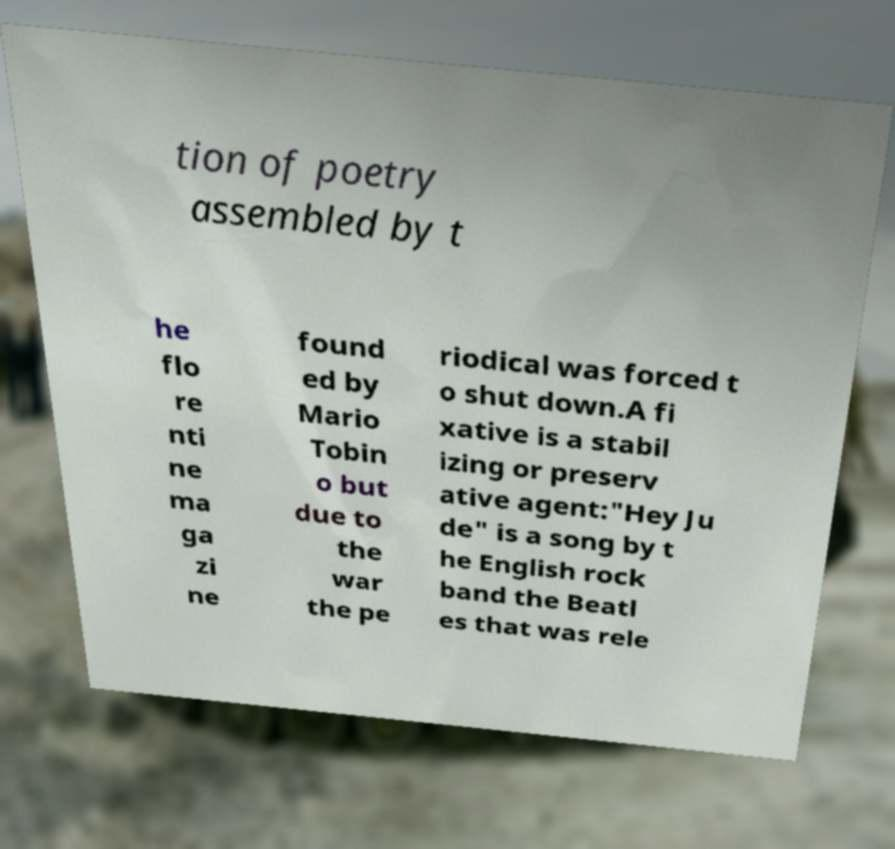What messages or text are displayed in this image? I need them in a readable, typed format. tion of poetry assembled by t he flo re nti ne ma ga zi ne found ed by Mario Tobin o but due to the war the pe riodical was forced t o shut down.A fi xative is a stabil izing or preserv ative agent:"Hey Ju de" is a song by t he English rock band the Beatl es that was rele 